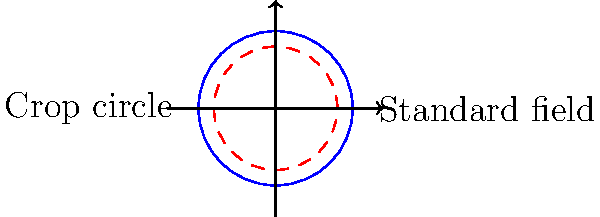A farmer notices a mysterious crop circle in his circular field. The crop circle's radius is 20% smaller than the original field's radius of 50 meters. Calculate the difference in perimeter between the standard field and the crop circle. How does this difference relate to the concept of pi and the scientific explanation for crop circles? Let's approach this problem step-by-step using scientific reasoning:

1) First, we need to calculate the radii:
   Standard field radius: $r_1 = 50$ m
   Crop circle radius: $r_2 = 50 \times 0.8 = 40$ m (20% smaller)

2) The formula for the perimeter (circumference) of a circle is $2\pi r$

3) For the standard field:
   $P_1 = 2\pi r_1 = 2\pi \times 50 = 100\pi$ m

4) For the crop circle:
   $P_2 = 2\pi r_2 = 2\pi \times 40 = 80\pi$ m

5) The difference in perimeter:
   $\Delta P = P_1 - P_2 = 100\pi - 80\pi = 20\pi$ m

6) To get a numerical value, we can use $\pi \approx 3.14159$:
   $\Delta P \approx 20 \times 3.14159 \approx 62.83$ m

This difference in perimeter is directly proportional to the difference in radii, which is always true for circles due to their geometric properties. The factor of $2\pi$ in the perimeter formula comes from the fundamental definition of pi as the ratio of a circle's circumference to its diameter.

From a scientific perspective, crop circles are typically explained as human-made phenomena, often created using simple tools like ropes and boards. The precise circular shape can be achieved by fixing a rope at the center and rotating it to flatten the crops. The 20% smaller radius could be due to the limited length of rope available or a deliberate choice by the creators.

The mathematical precision of the crop circle (being exactly 20% smaller) is more likely to be a result of human planning than any natural phenomenon, supporting the scientific explanation of crop circles as man-made artworks rather than supernatural occurrences.
Answer: $20\pi$ m or approximately 62.83 m 